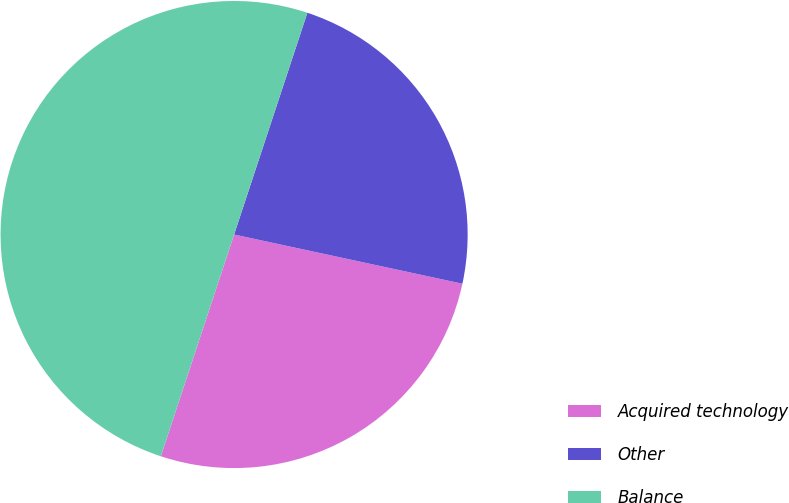Convert chart to OTSL. <chart><loc_0><loc_0><loc_500><loc_500><pie_chart><fcel>Acquired technology<fcel>Other<fcel>Balance<nl><fcel>26.7%<fcel>23.3%<fcel>50.0%<nl></chart> 